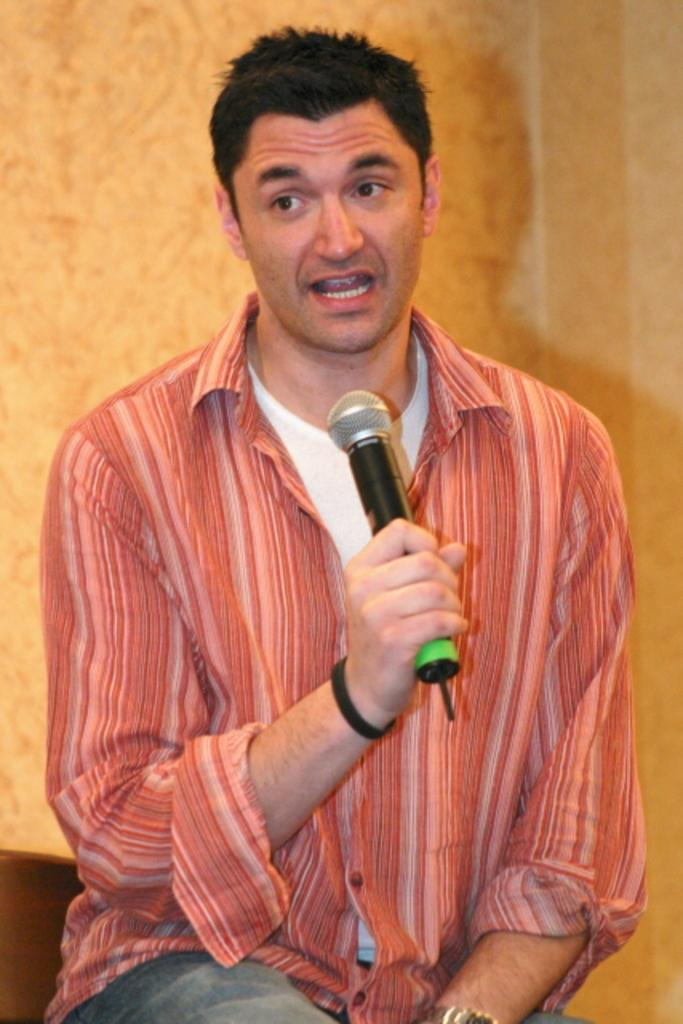What is the man in the image holding in his hand? The man is holding a microphone in his hand. What can be seen in the background of the image? There is a wall in the background of the image. How many legs does the egg have in the image? There is no egg present in the image, so it is not possible to determine the number of legs it might have. 